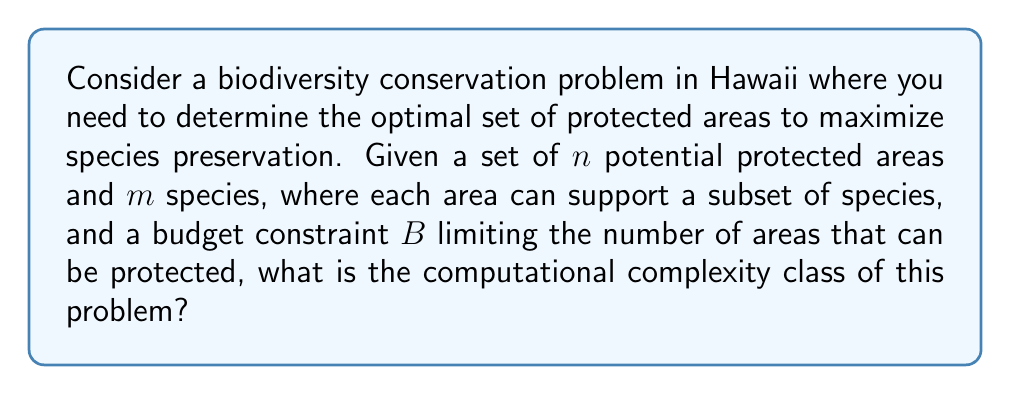Solve this math problem. To analyze the computational complexity of this problem, we need to consider its characteristics:

1. Decision problem formulation: "Is there a subset of protected areas that can preserve at least $k$ species within the budget $B$?"

2. This problem is a variant of the Set Cover problem, which is known to be NP-complete.

3. We can prove that this problem is NP-hard by reducing the Set Cover problem to it:
   - Let the universe of elements in Set Cover be the species.
   - Let each set in Set Cover correspond to a potential protected area.
   - Set the budget $B$ equal to the number of sets we're allowed to choose in Set Cover.
   - Set $k$ equal to the total number of elements (species) to be covered.

4. The problem is in NP because we can verify a solution in polynomial time:
   - Given a set of chosen protected areas, we can check if it's within the budget.
   - We can count the number of unique species covered by the chosen areas.
   - We can compare this count to $k$.

5. The optimization version (maximizing the number of species preserved) is at least as hard as the decision version.

6. There is no known polynomial-time algorithm for solving this problem exactly.

7. Approximation algorithms and heuristics are often used in practice for similar problems in conservation biology.

Given these characteristics, we can conclude that the problem belongs to the NP-hard complexity class. More specifically, the decision version is NP-complete.
Answer: The computational complexity class of the biodiversity conservation problem as described is NP-hard, with its decision version being NP-complete. 